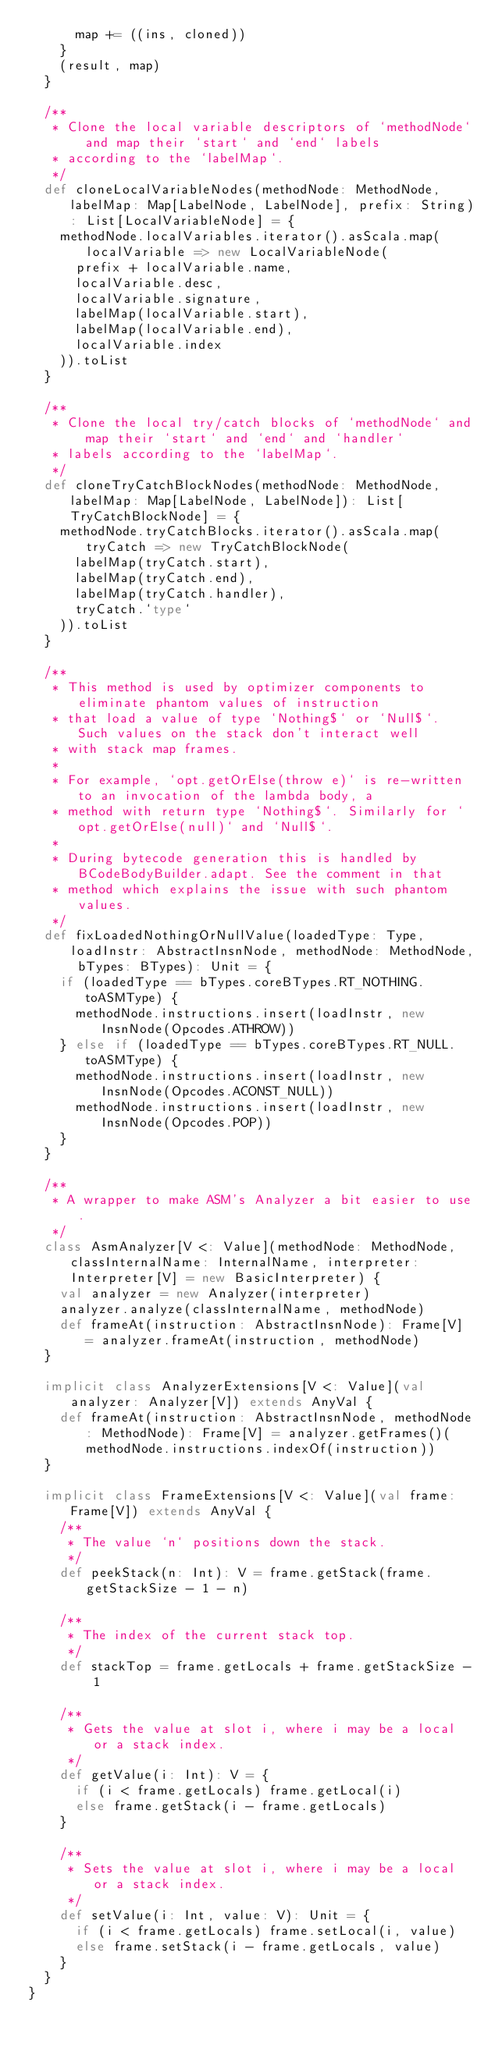<code> <loc_0><loc_0><loc_500><loc_500><_Scala_>      map += ((ins, cloned))
    }
    (result, map)
  }

  /**
   * Clone the local variable descriptors of `methodNode` and map their `start` and `end` labels
   * according to the `labelMap`.
   */
  def cloneLocalVariableNodes(methodNode: MethodNode, labelMap: Map[LabelNode, LabelNode], prefix: String): List[LocalVariableNode] = {
    methodNode.localVariables.iterator().asScala.map(localVariable => new LocalVariableNode(
      prefix + localVariable.name,
      localVariable.desc,
      localVariable.signature,
      labelMap(localVariable.start),
      labelMap(localVariable.end),
      localVariable.index
    )).toList
  }

  /**
   * Clone the local try/catch blocks of `methodNode` and map their `start` and `end` and `handler`
   * labels according to the `labelMap`.
   */
  def cloneTryCatchBlockNodes(methodNode: MethodNode, labelMap: Map[LabelNode, LabelNode]): List[TryCatchBlockNode] = {
    methodNode.tryCatchBlocks.iterator().asScala.map(tryCatch => new TryCatchBlockNode(
      labelMap(tryCatch.start),
      labelMap(tryCatch.end),
      labelMap(tryCatch.handler),
      tryCatch.`type`
    )).toList
  }

  /**
   * This method is used by optimizer components to eliminate phantom values of instruction
   * that load a value of type `Nothing$` or `Null$`. Such values on the stack don't interact well
   * with stack map frames.
   *
   * For example, `opt.getOrElse(throw e)` is re-written to an invocation of the lambda body, a
   * method with return type `Nothing$`. Similarly for `opt.getOrElse(null)` and `Null$`.
   *
   * During bytecode generation this is handled by BCodeBodyBuilder.adapt. See the comment in that
   * method which explains the issue with such phantom values.
   */
  def fixLoadedNothingOrNullValue(loadedType: Type, loadInstr: AbstractInsnNode, methodNode: MethodNode, bTypes: BTypes): Unit = {
    if (loadedType == bTypes.coreBTypes.RT_NOTHING.toASMType) {
      methodNode.instructions.insert(loadInstr, new InsnNode(Opcodes.ATHROW))
    } else if (loadedType == bTypes.coreBTypes.RT_NULL.toASMType) {
      methodNode.instructions.insert(loadInstr, new InsnNode(Opcodes.ACONST_NULL))
      methodNode.instructions.insert(loadInstr, new InsnNode(Opcodes.POP))
    }
  }

  /**
   * A wrapper to make ASM's Analyzer a bit easier to use.
   */
  class AsmAnalyzer[V <: Value](methodNode: MethodNode, classInternalName: InternalName, interpreter: Interpreter[V] = new BasicInterpreter) {
    val analyzer = new Analyzer(interpreter)
    analyzer.analyze(classInternalName, methodNode)
    def frameAt(instruction: AbstractInsnNode): Frame[V] = analyzer.frameAt(instruction, methodNode)
  }

  implicit class AnalyzerExtensions[V <: Value](val analyzer: Analyzer[V]) extends AnyVal {
    def frameAt(instruction: AbstractInsnNode, methodNode: MethodNode): Frame[V] = analyzer.getFrames()(methodNode.instructions.indexOf(instruction))
  }

  implicit class FrameExtensions[V <: Value](val frame: Frame[V]) extends AnyVal {
    /**
     * The value `n` positions down the stack.
     */
    def peekStack(n: Int): V = frame.getStack(frame.getStackSize - 1 - n)

    /**
     * The index of the current stack top.
     */
    def stackTop = frame.getLocals + frame.getStackSize - 1

    /**
     * Gets the value at slot i, where i may be a local or a stack index.
     */
    def getValue(i: Int): V = {
      if (i < frame.getLocals) frame.getLocal(i)
      else frame.getStack(i - frame.getLocals)
    }

    /**
     * Sets the value at slot i, where i may be a local or a stack index.
     */
    def setValue(i: Int, value: V): Unit = {
      if (i < frame.getLocals) frame.setLocal(i, value)
      else frame.setStack(i - frame.getLocals, value)
    }
  }
}
</code> 